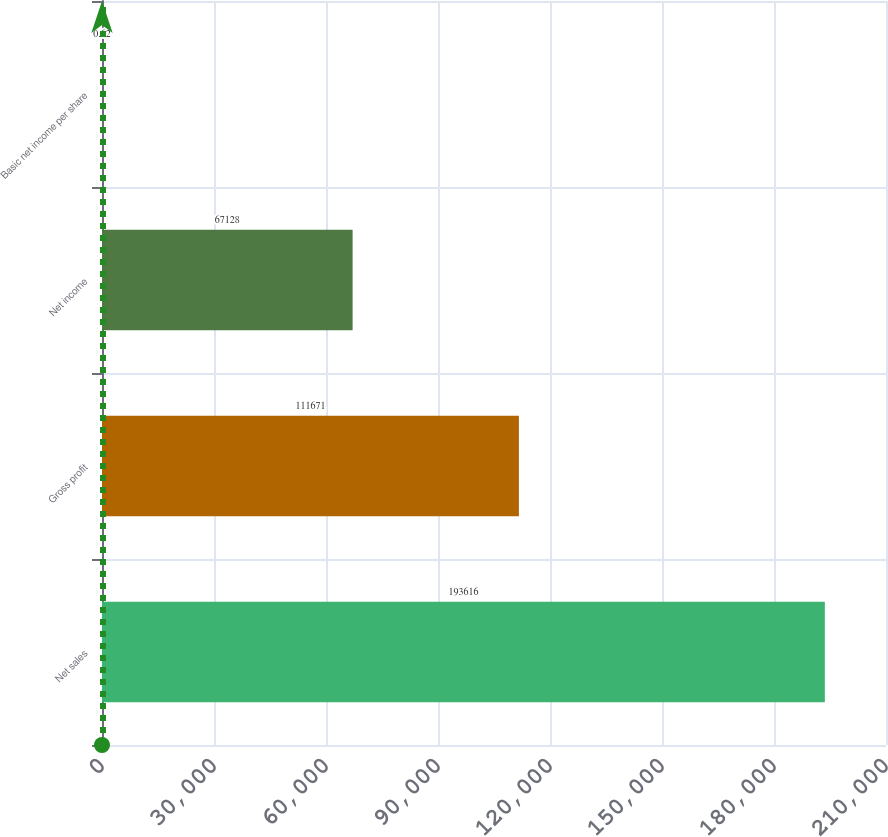Convert chart to OTSL. <chart><loc_0><loc_0><loc_500><loc_500><bar_chart><fcel>Net sales<fcel>Gross profit<fcel>Net income<fcel>Basic net income per share<nl><fcel>193616<fcel>111671<fcel>67128<fcel>0.62<nl></chart> 